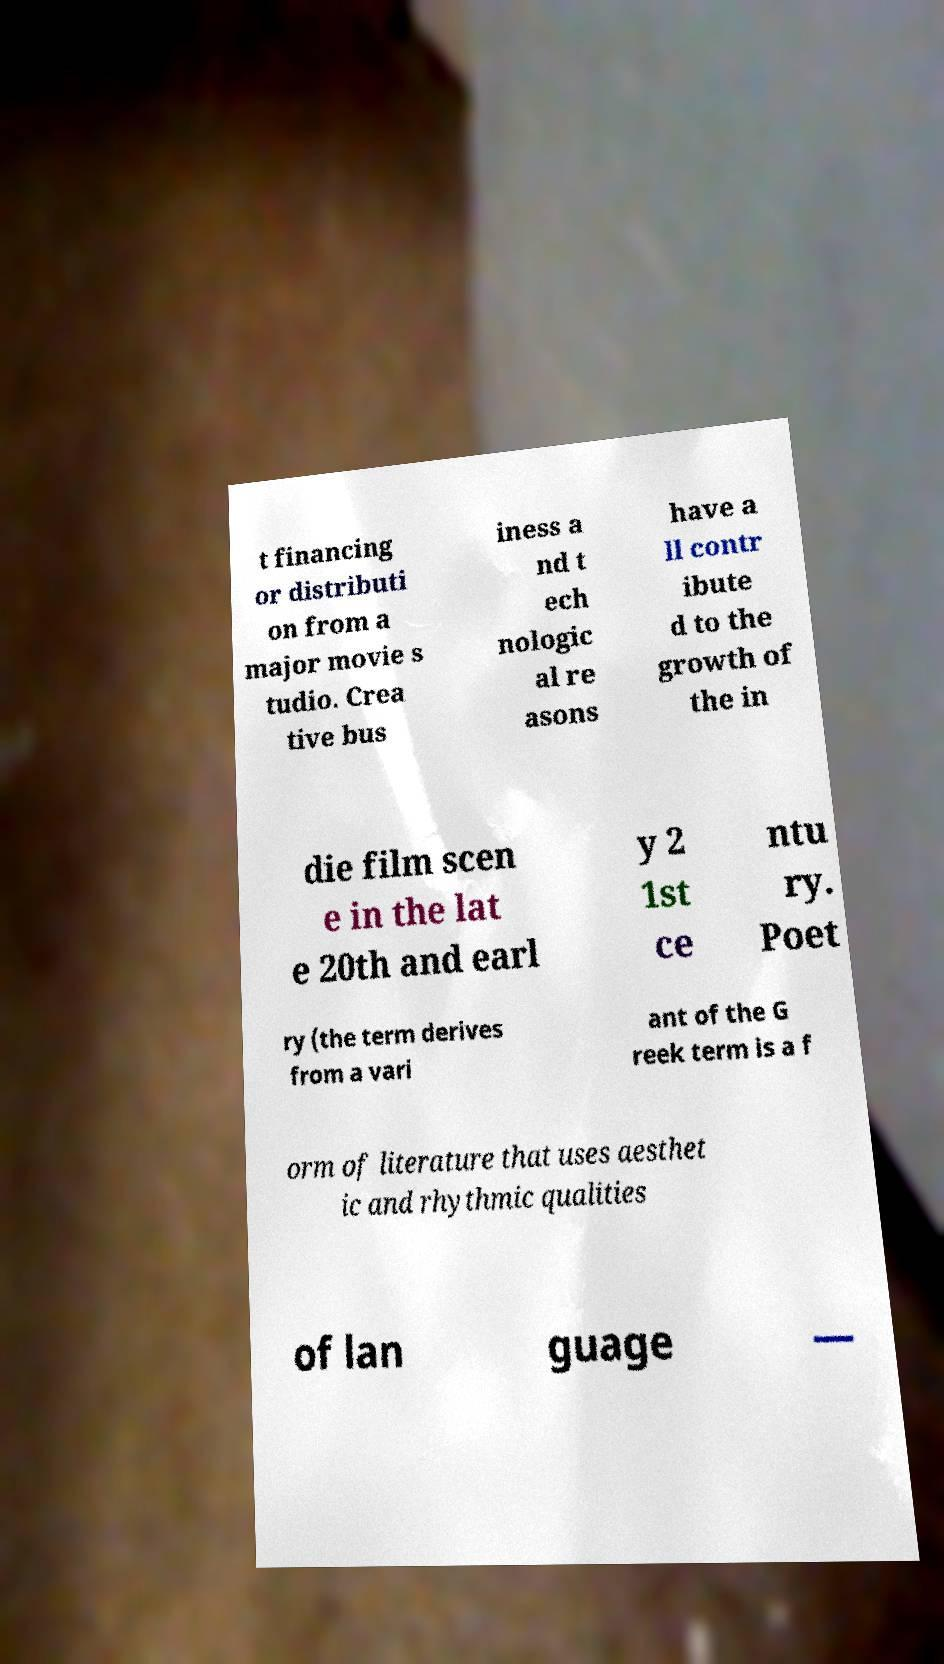Please identify and transcribe the text found in this image. t financing or distributi on from a major movie s tudio. Crea tive bus iness a nd t ech nologic al re asons have a ll contr ibute d to the growth of the in die film scen e in the lat e 20th and earl y 2 1st ce ntu ry. Poet ry (the term derives from a vari ant of the G reek term is a f orm of literature that uses aesthet ic and rhythmic qualities of lan guage — 